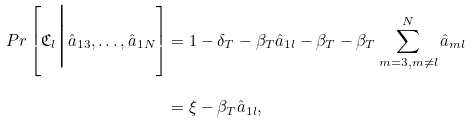Convert formula to latex. <formula><loc_0><loc_0><loc_500><loc_500>P r \left [ \mathfrak { C } _ { l } \Big | \hat { a } _ { 1 3 } , \dots , \hat { a } _ { 1 N } \right ] & = 1 - \delta _ { T } - \beta _ { T } \hat { a } _ { 1 l } - \beta _ { T } - \beta _ { T } \sum ^ { N } _ { m = 3 , m \neq l } \hat { a } _ { m l } \\ & = \xi - \beta _ { T } \hat { a } _ { 1 l } ,</formula> 